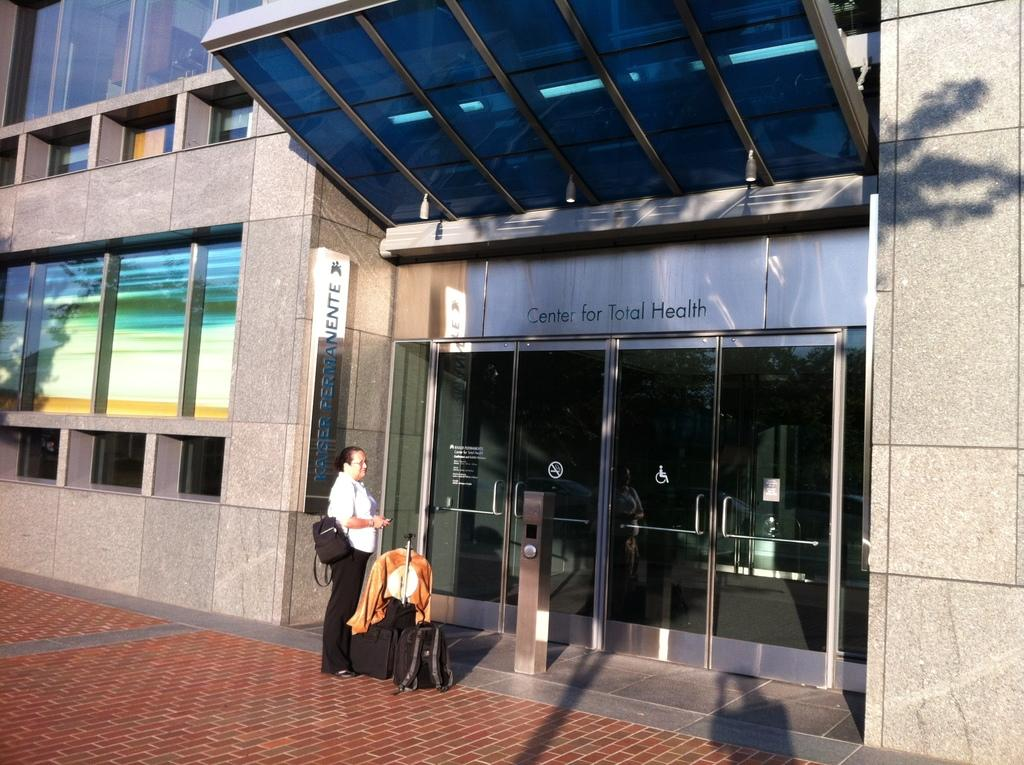What type of structure is visible in the image? There is a building in the image. What feature can be observed on the building? The building has glass windows and glass doors. What is happening in front of the building? A person is standing in front of the building. What items does the person have beside them? The person has luggage and a bag beside them. What type of mint is growing on the building in the image? There is no mint growing on the building in the image. Can you see a chair on the building in the image? There is no chair visible on the building in the image. 